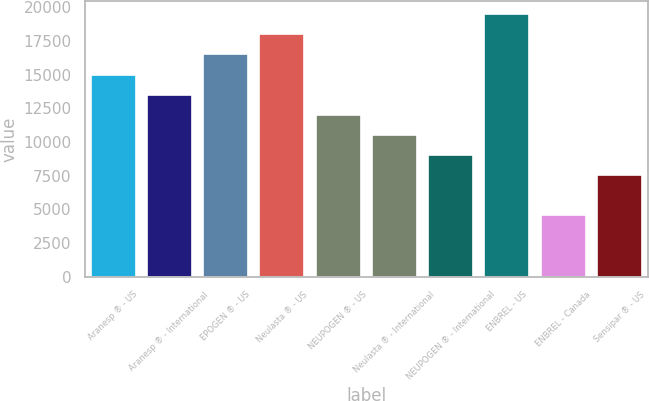<chart> <loc_0><loc_0><loc_500><loc_500><bar_chart><fcel>Aranesp ® - US<fcel>Aranesp ® - International<fcel>EPOGEN ® - US<fcel>Neulasta ® - US<fcel>NEUPOGEN ® - US<fcel>Neulasta ® - International<fcel>NEUPOGEN ® - International<fcel>ENBREL - US<fcel>ENBREL - Canada<fcel>Sensipar ® - US<nl><fcel>15003<fcel>13511.6<fcel>16494.4<fcel>17985.8<fcel>12020.2<fcel>10528.8<fcel>9037.4<fcel>19477.2<fcel>4563.2<fcel>7546<nl></chart> 